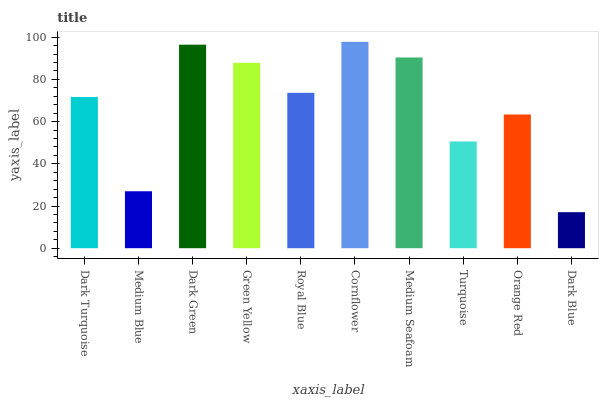Is Dark Blue the minimum?
Answer yes or no. Yes. Is Cornflower the maximum?
Answer yes or no. Yes. Is Medium Blue the minimum?
Answer yes or no. No. Is Medium Blue the maximum?
Answer yes or no. No. Is Dark Turquoise greater than Medium Blue?
Answer yes or no. Yes. Is Medium Blue less than Dark Turquoise?
Answer yes or no. Yes. Is Medium Blue greater than Dark Turquoise?
Answer yes or no. No. Is Dark Turquoise less than Medium Blue?
Answer yes or no. No. Is Royal Blue the high median?
Answer yes or no. Yes. Is Dark Turquoise the low median?
Answer yes or no. Yes. Is Dark Turquoise the high median?
Answer yes or no. No. Is Royal Blue the low median?
Answer yes or no. No. 